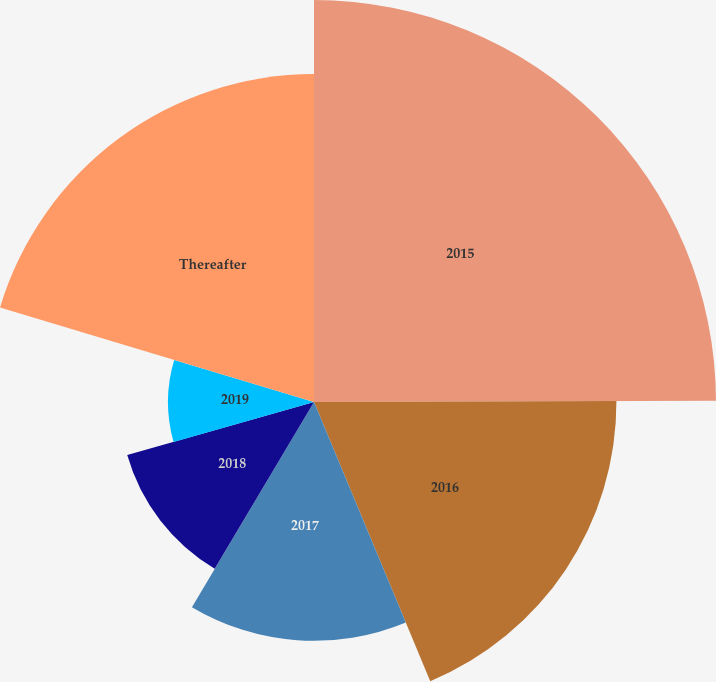<chart> <loc_0><loc_0><loc_500><loc_500><pie_chart><fcel>2015<fcel>2016<fcel>2017<fcel>2018<fcel>2019<fcel>Thereafter<nl><fcel>24.95%<fcel>18.77%<fcel>14.82%<fcel>12.05%<fcel>9.06%<fcel>20.35%<nl></chart> 